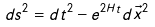<formula> <loc_0><loc_0><loc_500><loc_500>d s ^ { 2 } = d t ^ { 2 } - e ^ { 2 H t } d \vec { x } ^ { 2 }</formula> 